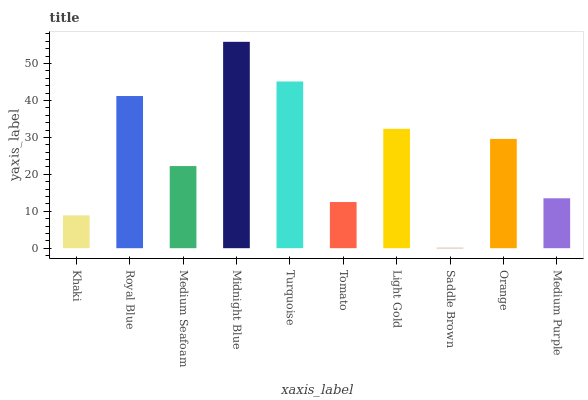Is Royal Blue the minimum?
Answer yes or no. No. Is Royal Blue the maximum?
Answer yes or no. No. Is Royal Blue greater than Khaki?
Answer yes or no. Yes. Is Khaki less than Royal Blue?
Answer yes or no. Yes. Is Khaki greater than Royal Blue?
Answer yes or no. No. Is Royal Blue less than Khaki?
Answer yes or no. No. Is Orange the high median?
Answer yes or no. Yes. Is Medium Seafoam the low median?
Answer yes or no. Yes. Is Light Gold the high median?
Answer yes or no. No. Is Orange the low median?
Answer yes or no. No. 